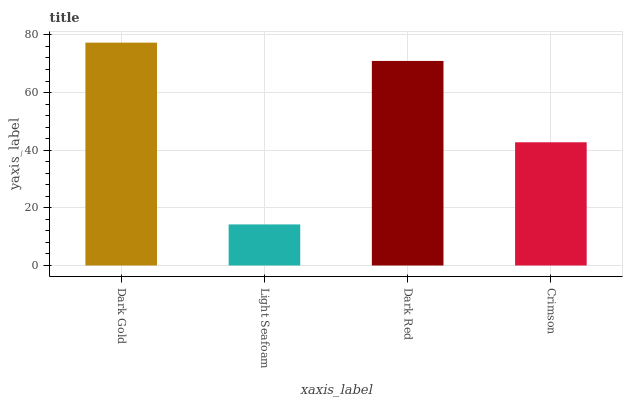Is Light Seafoam the minimum?
Answer yes or no. Yes. Is Dark Gold the maximum?
Answer yes or no. Yes. Is Dark Red the minimum?
Answer yes or no. No. Is Dark Red the maximum?
Answer yes or no. No. Is Dark Red greater than Light Seafoam?
Answer yes or no. Yes. Is Light Seafoam less than Dark Red?
Answer yes or no. Yes. Is Light Seafoam greater than Dark Red?
Answer yes or no. No. Is Dark Red less than Light Seafoam?
Answer yes or no. No. Is Dark Red the high median?
Answer yes or no. Yes. Is Crimson the low median?
Answer yes or no. Yes. Is Light Seafoam the high median?
Answer yes or no. No. Is Dark Red the low median?
Answer yes or no. No. 